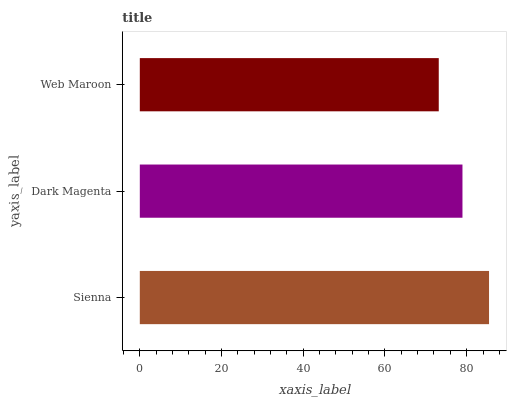Is Web Maroon the minimum?
Answer yes or no. Yes. Is Sienna the maximum?
Answer yes or no. Yes. Is Dark Magenta the minimum?
Answer yes or no. No. Is Dark Magenta the maximum?
Answer yes or no. No. Is Sienna greater than Dark Magenta?
Answer yes or no. Yes. Is Dark Magenta less than Sienna?
Answer yes or no. Yes. Is Dark Magenta greater than Sienna?
Answer yes or no. No. Is Sienna less than Dark Magenta?
Answer yes or no. No. Is Dark Magenta the high median?
Answer yes or no. Yes. Is Dark Magenta the low median?
Answer yes or no. Yes. Is Web Maroon the high median?
Answer yes or no. No. Is Sienna the low median?
Answer yes or no. No. 